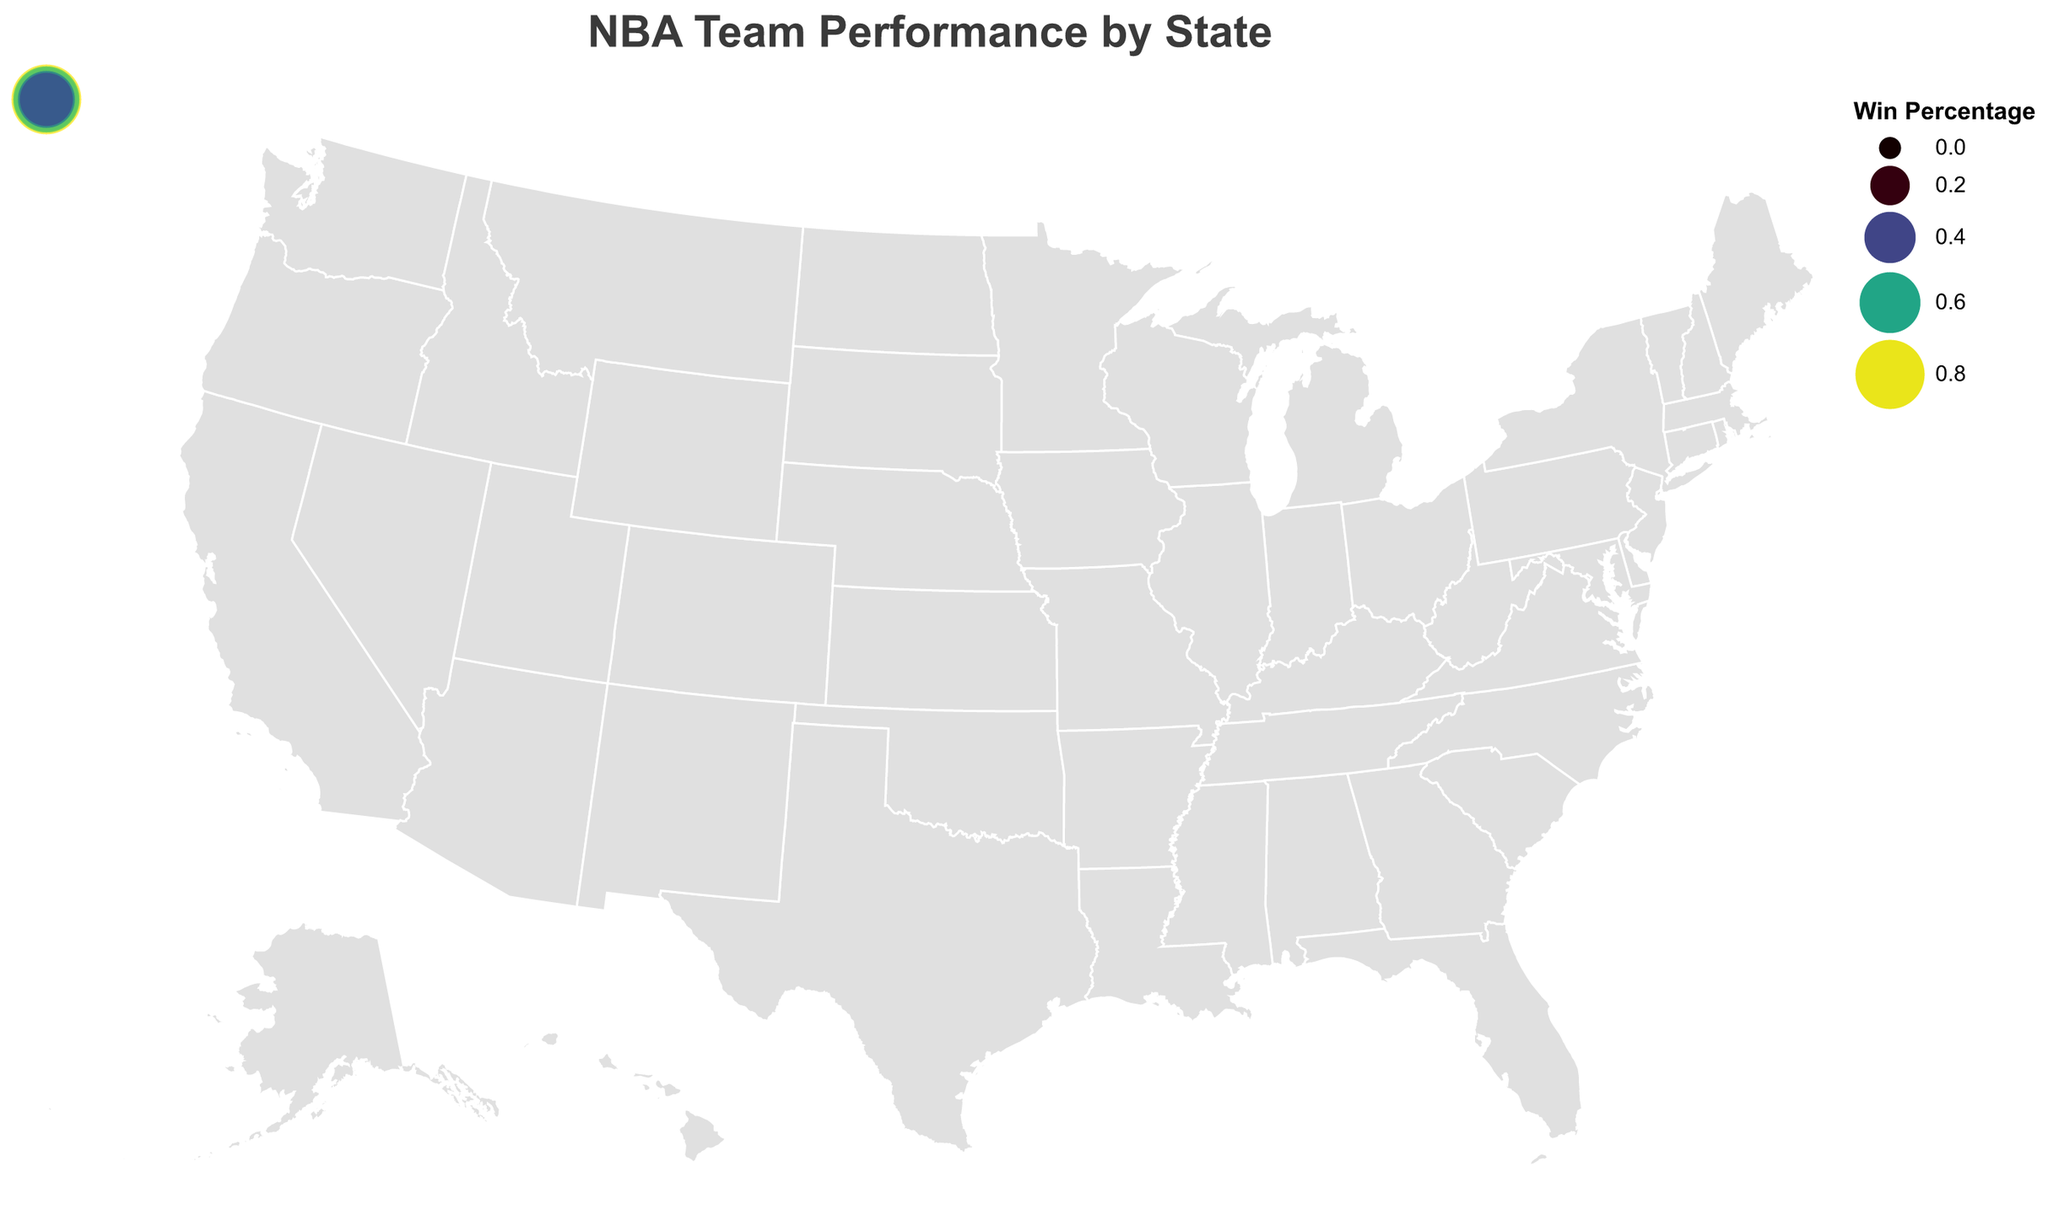How many NBA teams have a win percentage below 0.5? By examining the circle sizes and tooltips, we identify teams with win percentages below 0.5: Sacramento Kings, Orlando Magic, New York Knicks, Detroit Pistons, Indiana Pacers, Minnesota Timberwolves, Charlotte Hornets, Washington Wizards, and New Orleans Pelicans. There are 9 teams.
Answer: 9 Which state has the team with the highest win percentage? The largest circle with the highest color intensity is for the Golden State Warriors in California, with a win percentage of 0.817.
Answer: California What's the average win percentage of NBA teams in Texas? The win percentages for teams in Texas are: San Antonio Spurs (0.732), Houston Rockets (0.610), Dallas Mavericks (0.573). The average is (0.732 + 0.610 + 0.573) / 3 = 0.638.
Answer: 0.638 Which NBA team in New York has a lower win percentage? Comparing the win percentages for teams in New York, Brooklyn Nets (0.585) and New York Knicks (0.415), New York Knicks have a lower win percentage.
Answer: New York Knicks How many states have only one NBA team? By inspecting the geographic distribution and count of teams per state: Massachusetts (Boston Celtics), Pennsylvania (Philadelphia 76ers), Ohio (Cleveland Cavaliers), Wisconsin (Milwaukee Bucks), Michigan (Detroit Pistons), Indiana (Indiana Pacers), Minnesota (Minnesota Timberwolves), Colorado (Denver Nuggets), Utah (Utah Jazz), Oregon (Portland Trail Blazers), Oklahoma (Oklahoma City Thunder), Arizona (Phoenix Suns), Tennessee (Memphis Grizzlies), North Carolina (Charlotte Hornets), Georgia (Atlanta Hawks), Washington (Washington Wizards), Louisiana (New Orleans Pelicans). Therefore, 17 states have only one team.
Answer: 17 